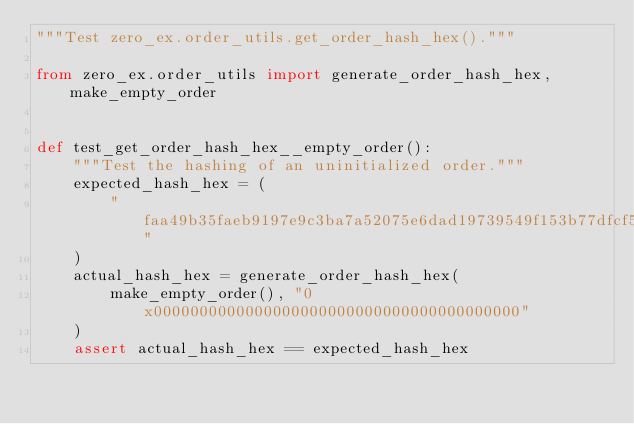Convert code to text. <code><loc_0><loc_0><loc_500><loc_500><_Python_>"""Test zero_ex.order_utils.get_order_hash_hex()."""

from zero_ex.order_utils import generate_order_hash_hex, make_empty_order


def test_get_order_hash_hex__empty_order():
    """Test the hashing of an uninitialized order."""
    expected_hash_hex = (
        "faa49b35faeb9197e9c3ba7a52075e6dad19739549f153b77dfcf59408a4b422"
    )
    actual_hash_hex = generate_order_hash_hex(
        make_empty_order(), "0x0000000000000000000000000000000000000000"
    )
    assert actual_hash_hex == expected_hash_hex
</code> 